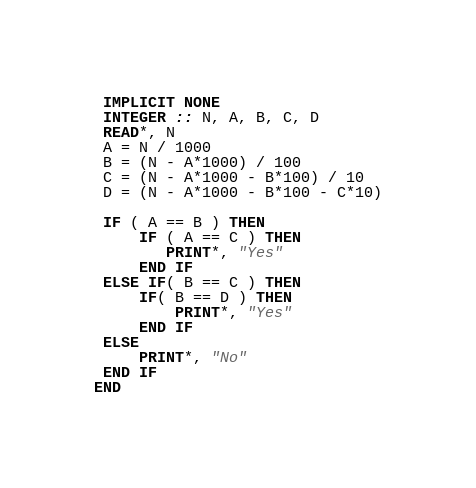<code> <loc_0><loc_0><loc_500><loc_500><_FORTRAN_> IMPLICIT NONE
 INTEGER :: N, A, B, C, D
 READ*, N
 A = N / 1000
 B = (N - A*1000) / 100
 C = (N - A*1000 - B*100) / 10
 D = (N - A*1000 - B*100 - C*10)
 
 IF ( A == B ) THEN
     IF ( A == C ) THEN 
     	PRINT*, "Yes"
     END IF
 ELSE IF( B == C ) THEN
     IF( B == D ) THEN
         PRINT*, "Yes"
     END IF
 ELSE
     PRINT*, "No"
 END IF
END</code> 